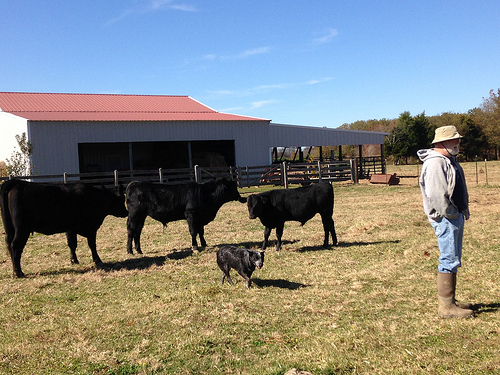<image>
Can you confirm if the sky is behind the shed? Yes. From this viewpoint, the sky is positioned behind the shed, with the shed partially or fully occluding the sky. Where is the cow in relation to the cow? Is it on the cow? No. The cow is not positioned on the cow. They may be near each other, but the cow is not supported by or resting on top of the cow. Where is the cow in relation to the farmer? Is it to the left of the farmer? Yes. From this viewpoint, the cow is positioned to the left side relative to the farmer. 